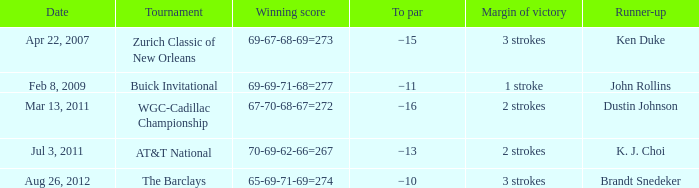In the competition where ken duke was a runner-up, what was the top par? −15. 